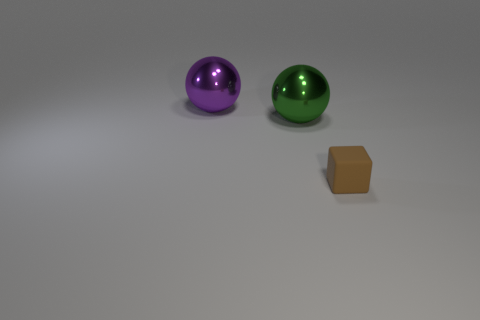Add 2 big green metallic objects. How many objects exist? 5 Add 1 brown rubber cubes. How many brown rubber cubes are left? 2 Add 1 big green metallic spheres. How many big green metallic spheres exist? 2 Subtract 0 red balls. How many objects are left? 3 Subtract all spheres. How many objects are left? 1 Subtract all large balls. Subtract all big cyan shiny things. How many objects are left? 1 